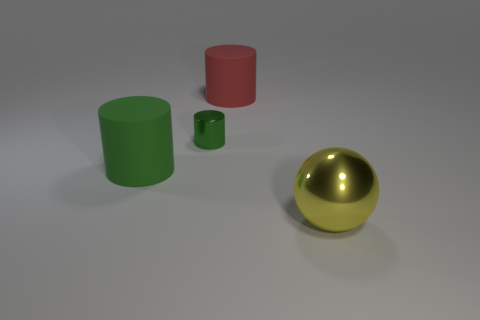Is there any other thing that is the same size as the shiny cylinder? It seems there is no object identical in size to the shiny cylinder. The other objects include a larger green cylinder, a smaller red cylinder, and a golden sphere, each differing in size. 